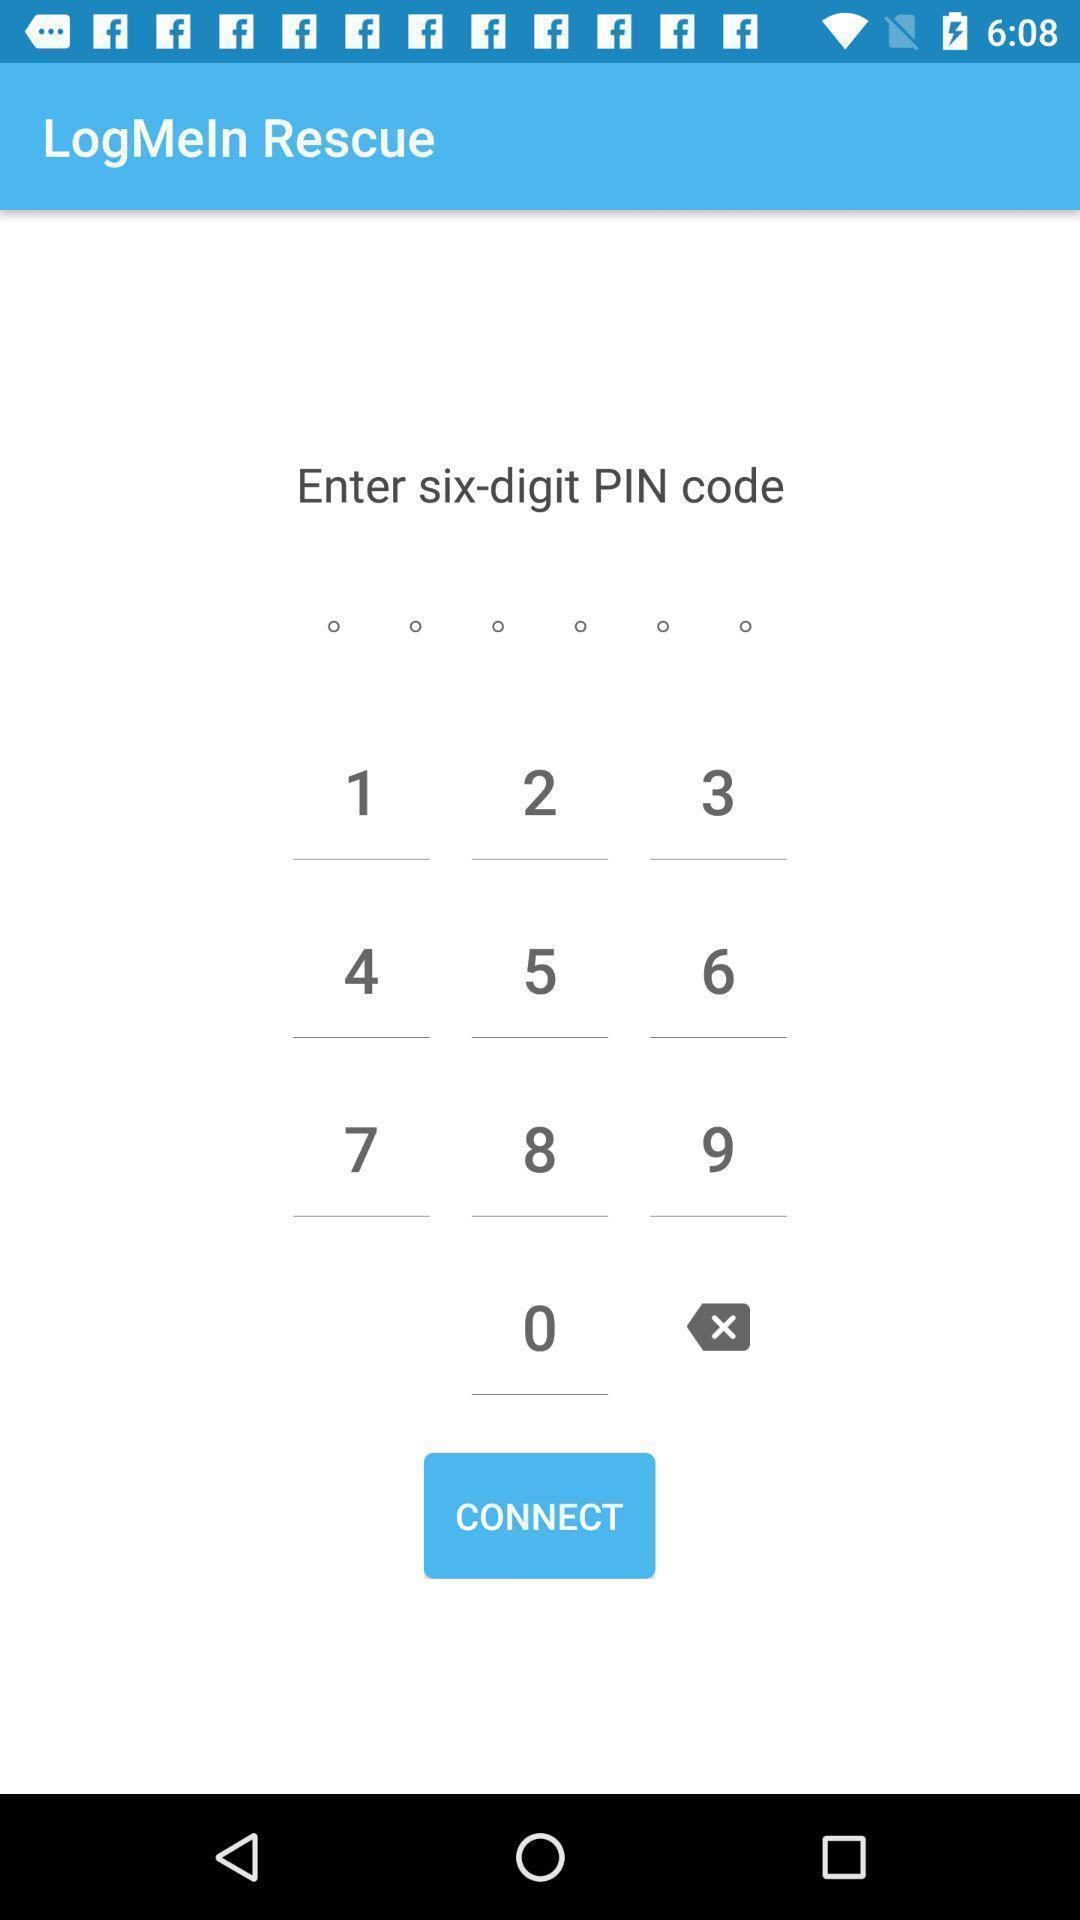Give me a summary of this screen capture. Page to write pin code in the app. 